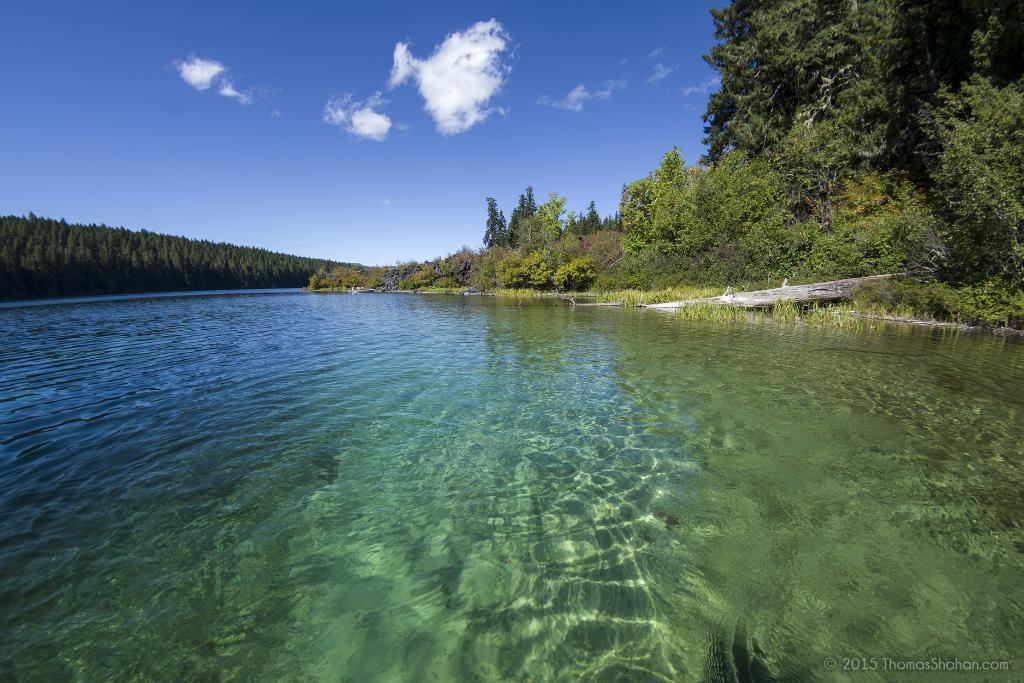In one or two sentences, can you explain what this image depicts? On the bottom right, there is a watermark. In the middle of this image, there is water of a river. On both sides of this river, there are trees on the ground. In the background, there are clouds in the blue sky. 